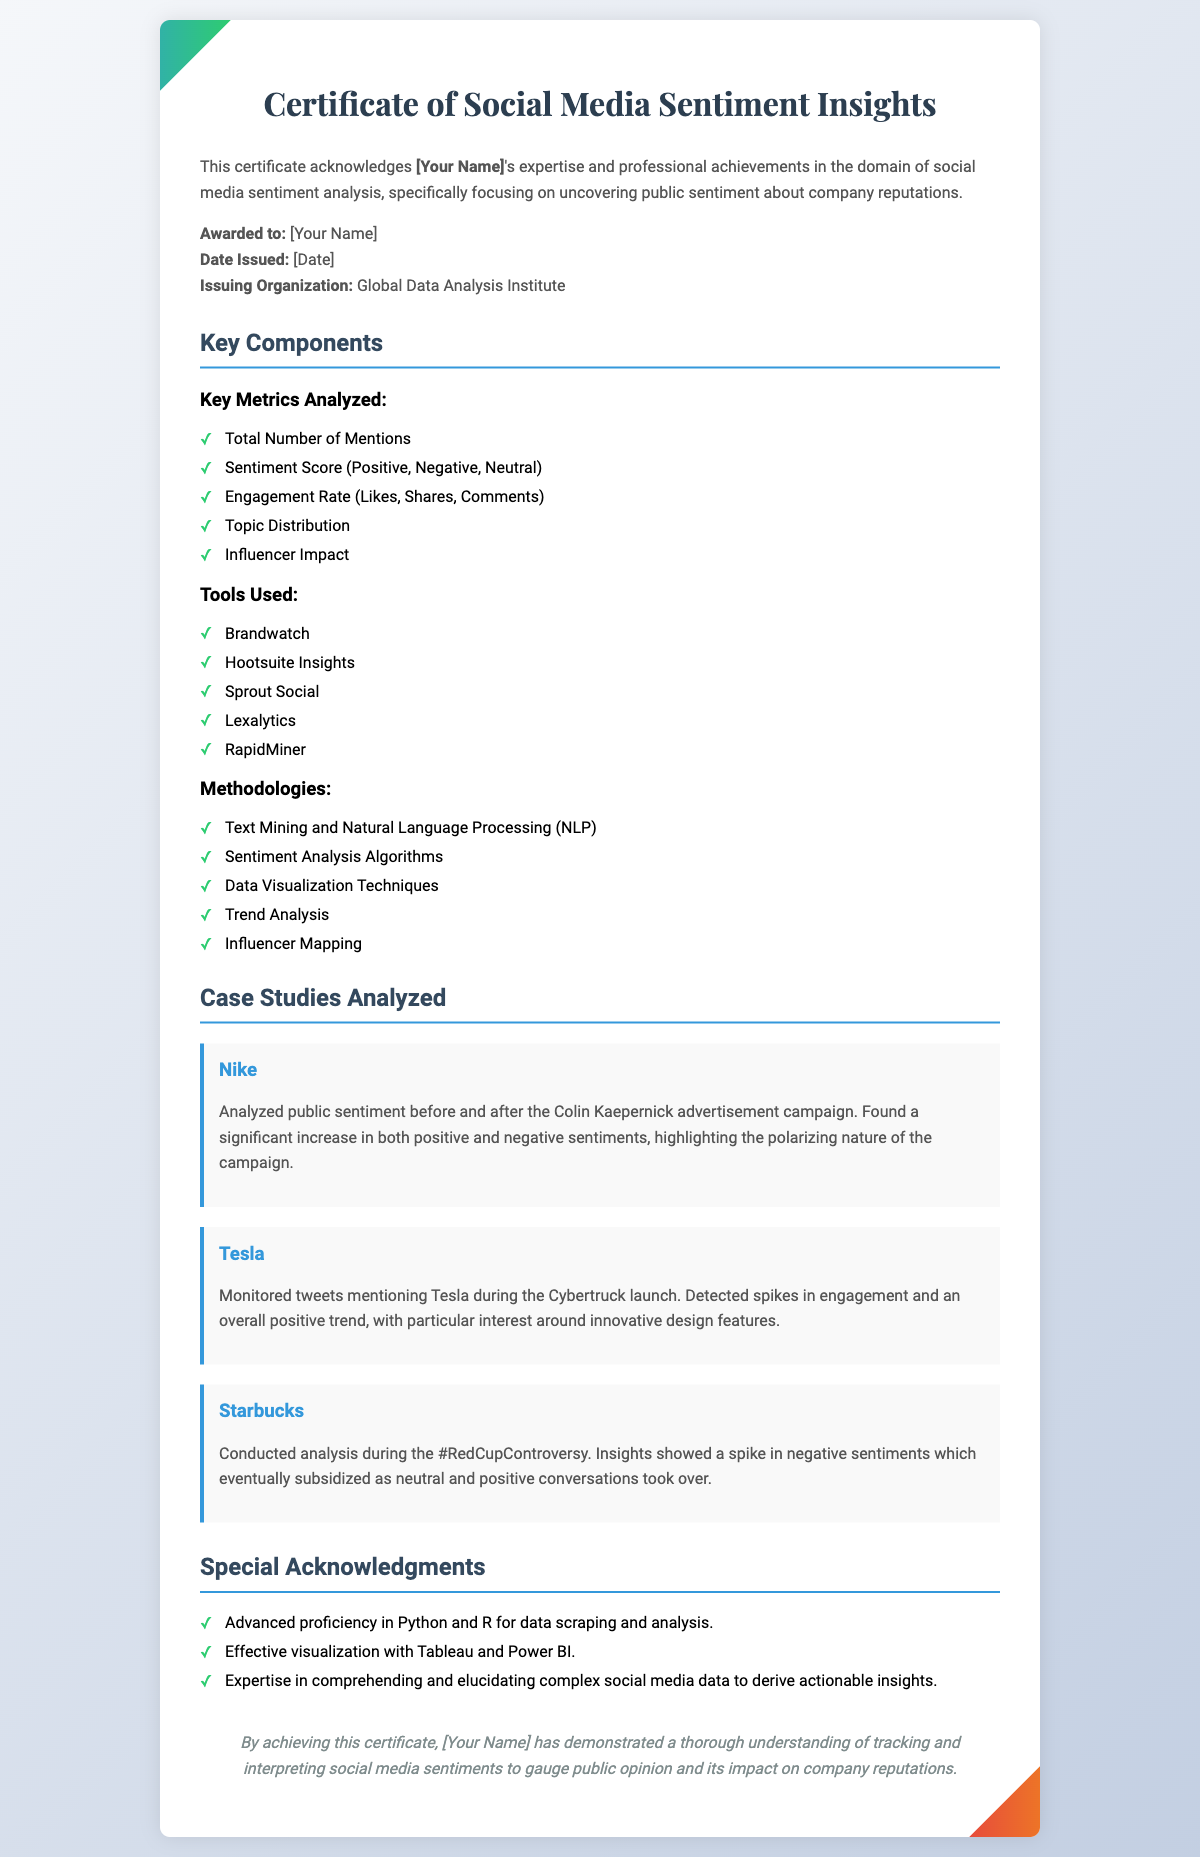what is the title of the certificate? The title of the certificate as stated in the document is "Certificate of Social Media Sentiment Insights."
Answer: Certificate of Social Media Sentiment Insights who is the issuing organization? The document provides the name of the organization that issued the certificate, which is stated as "Global Data Analysis Institute."
Answer: Global Data Analysis Institute what is the date format used in the certificate? The document specifies that the date is included in the format "Date Issued: [Date]." The exact format is not provided, but it indicates the use of "[Date]" placeholder.
Answer: [Date] name one tool used for sentiment analysis mentioned in the document. The document lists several tools utilized for sentiment analysis, one of which is "Brandwatch."
Answer: Brandwatch how many case studies are analyzed in the certificate? The document mentions three specific case studies that were analyzed, one each for Nike, Tesla, and Starbucks.
Answer: 3 what methodology involves analyzing public sentiment trends? The document includes "Trend Analysis" as one of the methodologies used in the analysis.
Answer: Trend Analysis what is a key metric analyzed on social media mentioned in the document? The document lists multiple key metrics, including "Sentiment Score (Positive, Negative, Neutral)."
Answer: Sentiment Score (Positive, Negative, Neutral) what type of data analysis proficiency is acknowledged in the special acknowledgments? The document acknowledges "Advanced proficiency in Python and R for data scraping and analysis."
Answer: Advanced proficiency in Python and R who is awarded the certificate? The certificate is awarded to the individual whose name is indicated as "[Your Name]."
Answer: [Your Name] 